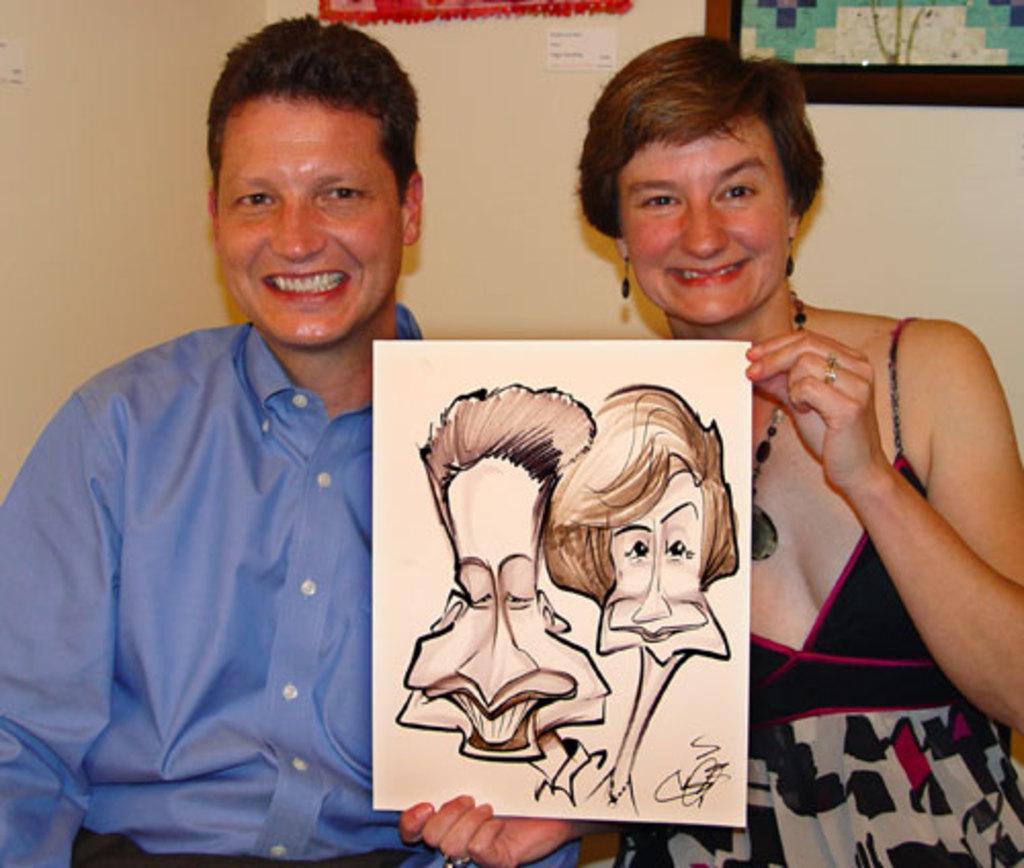In one or two sentences, can you explain what this image depicts? In the image there is a man in blue shirt standing beside a woman in black dress holding a painting and behind them there is wall with painting on it. 